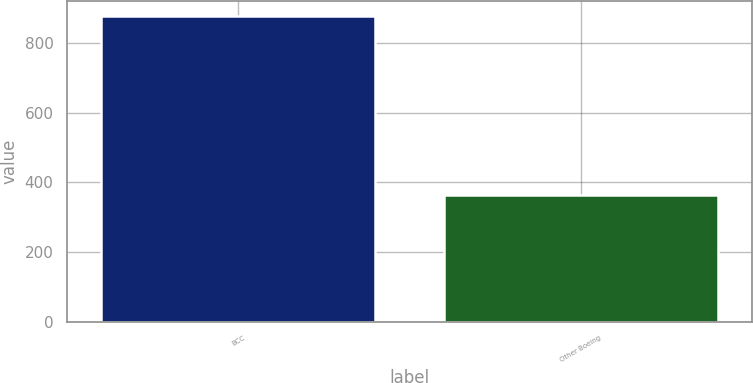<chart> <loc_0><loc_0><loc_500><loc_500><bar_chart><fcel>BCC<fcel>Other Boeing<nl><fcel>878<fcel>363<nl></chart> 